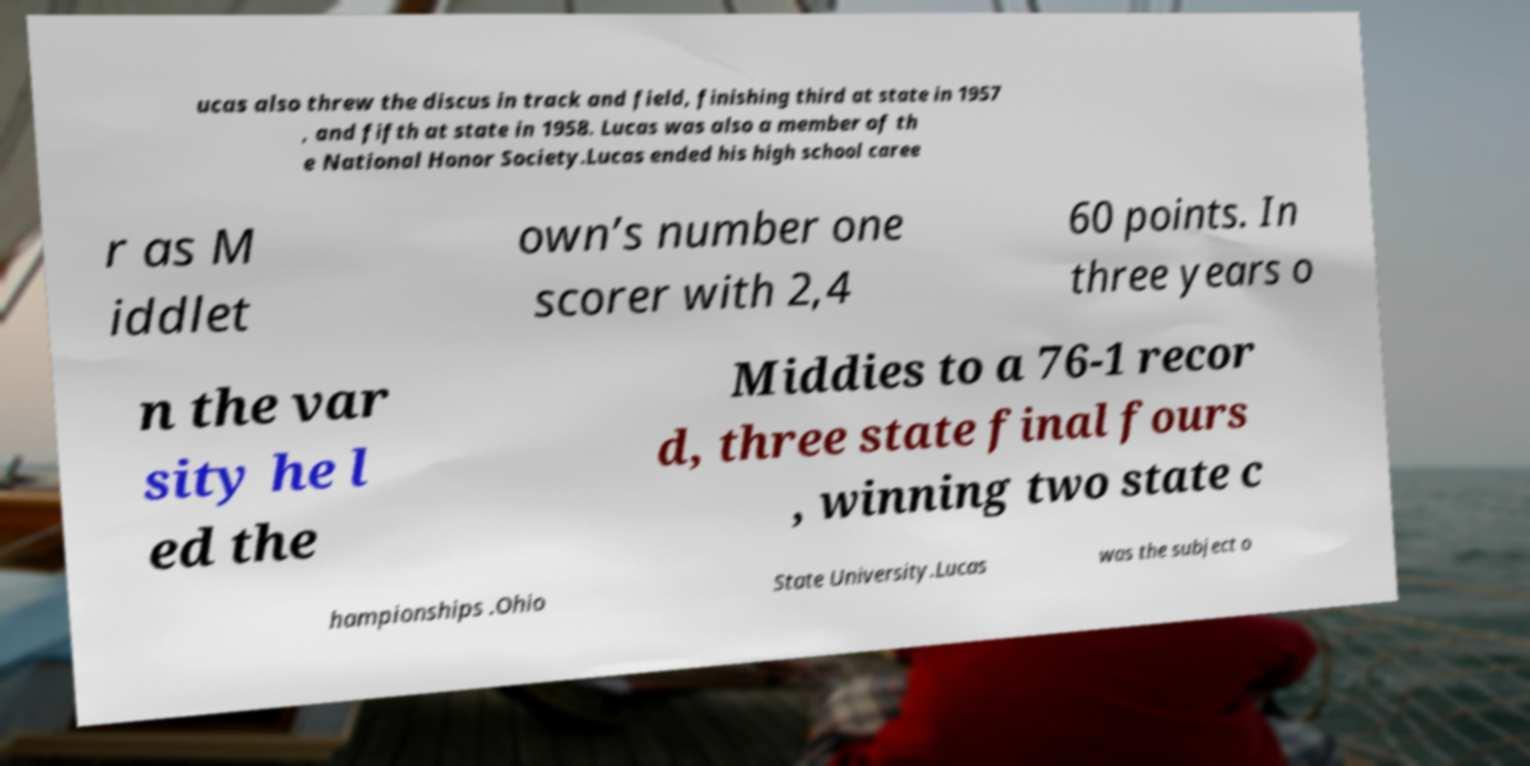What messages or text are displayed in this image? I need them in a readable, typed format. ucas also threw the discus in track and field, finishing third at state in 1957 , and fifth at state in 1958. Lucas was also a member of th e National Honor Society.Lucas ended his high school caree r as M iddlet own’s number one scorer with 2,4 60 points. In three years o n the var sity he l ed the Middies to a 76-1 recor d, three state final fours , winning two state c hampionships .Ohio State University.Lucas was the subject o 